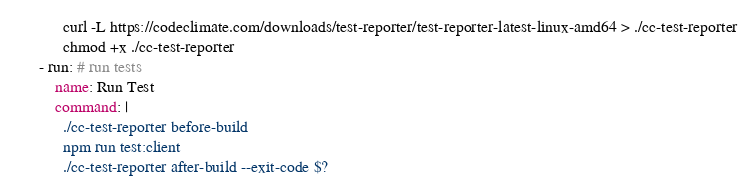<code> <loc_0><loc_0><loc_500><loc_500><_YAML_>            curl -L https://codeclimate.com/downloads/test-reporter/test-reporter-latest-linux-amd64 > ./cc-test-reporter
            chmod +x ./cc-test-reporter
      - run: # run tests
          name: Run Test
          command: |
            ./cc-test-reporter before-build
            npm run test:client
            ./cc-test-reporter after-build --exit-code $?
</code> 